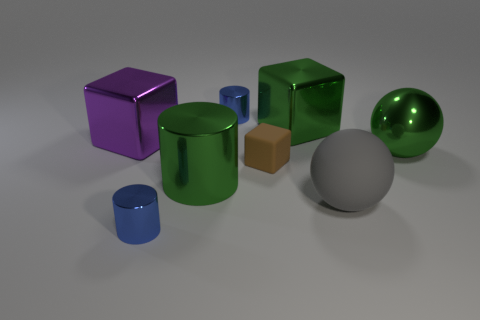Add 1 blue matte spheres. How many objects exist? 9 Subtract all balls. How many objects are left? 6 Subtract all small yellow objects. Subtract all matte cubes. How many objects are left? 7 Add 3 cylinders. How many cylinders are left? 6 Add 2 large brown balls. How many large brown balls exist? 2 Subtract 1 green blocks. How many objects are left? 7 